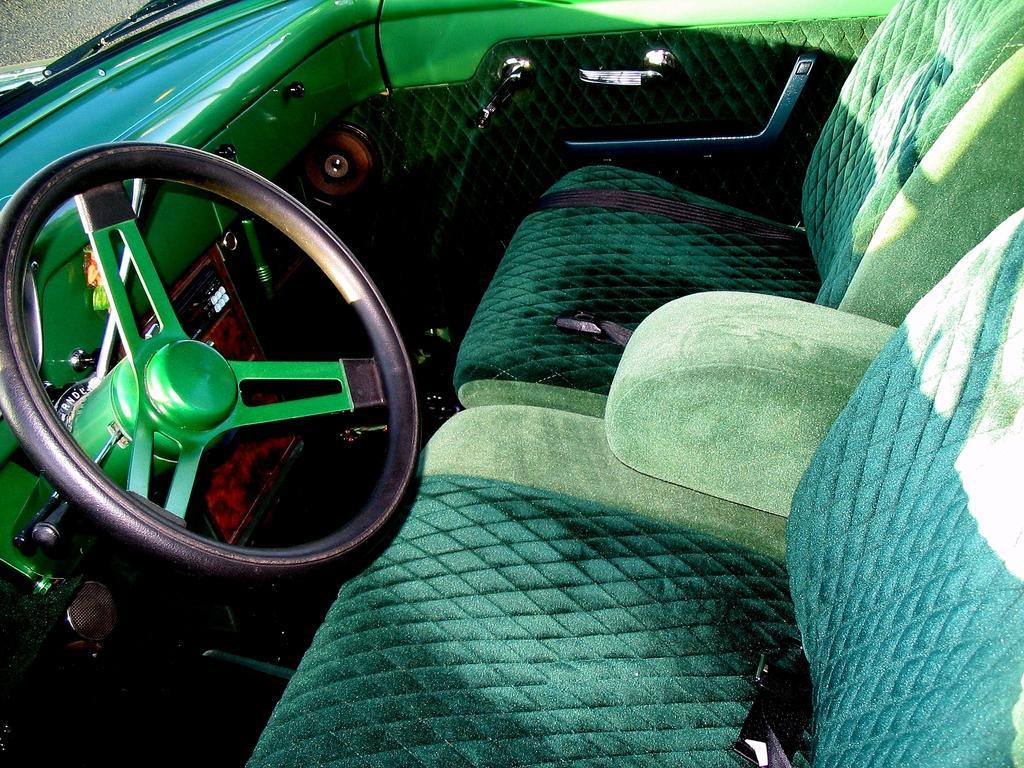Can you describe this image briefly? In this image I can see steering. It is black and green color. We can see two seats and seat belts. They are in green color. 